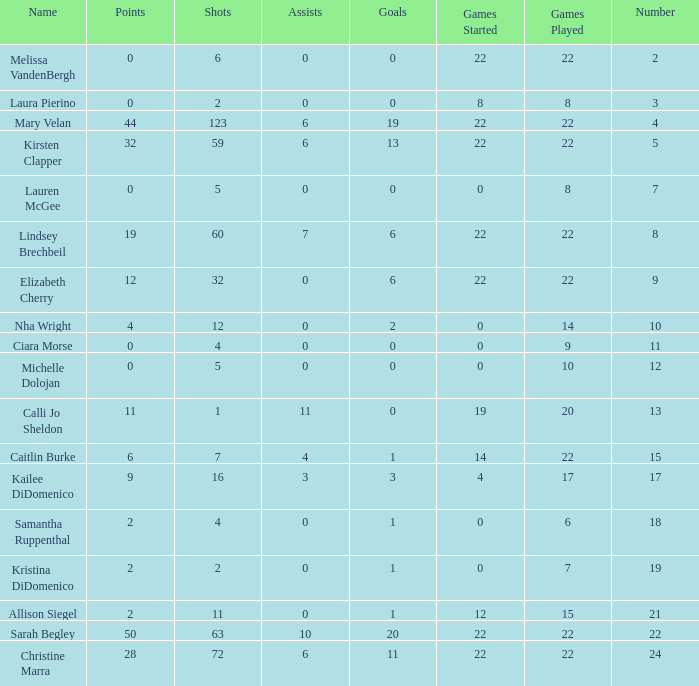How many names are listed for the player with 50 points? 1.0. 